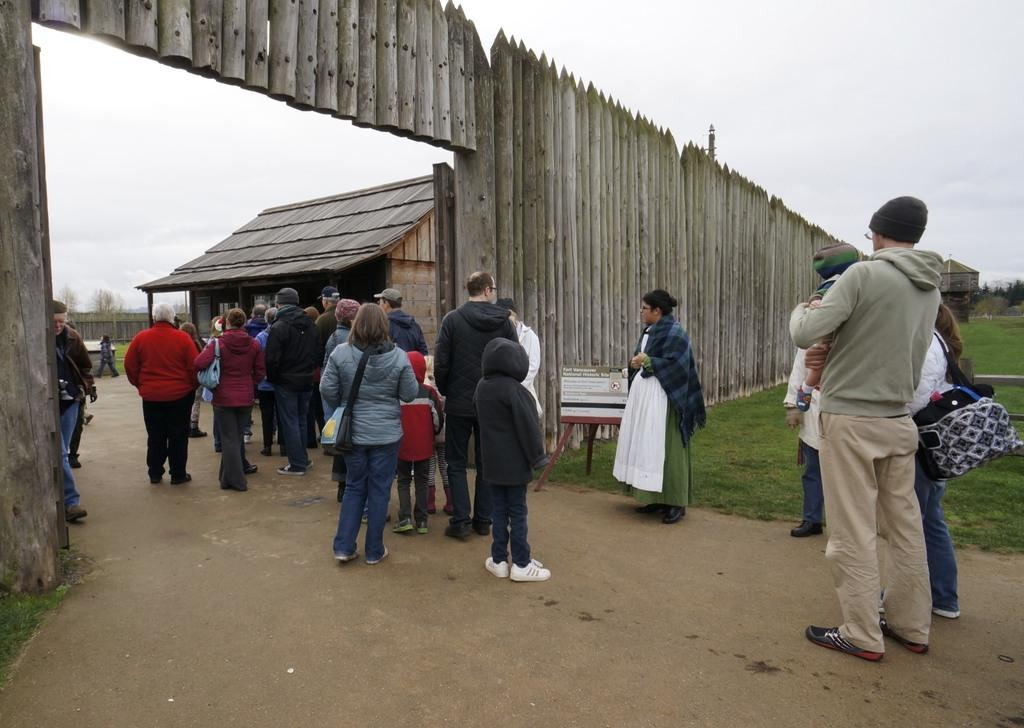What can be seen in the image? There are people standing in the image. What are the people wearing? The people are wearing jackets. What type of structure is present in the image? There is a wooden building in the image. What is the fencing made of in the image? The fencing in the image is made of wood. What is the ground covered with in the image? The ground is covered with grass. Who is the representative of the group in the image? There is no indication in the image that a specific person is a representative of the group. 